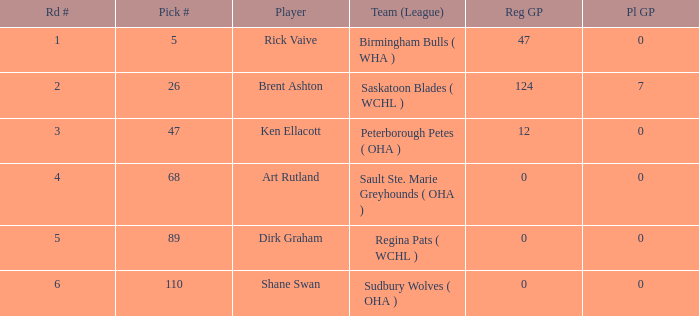How many regular gp for rick vaive in the first round? None. 